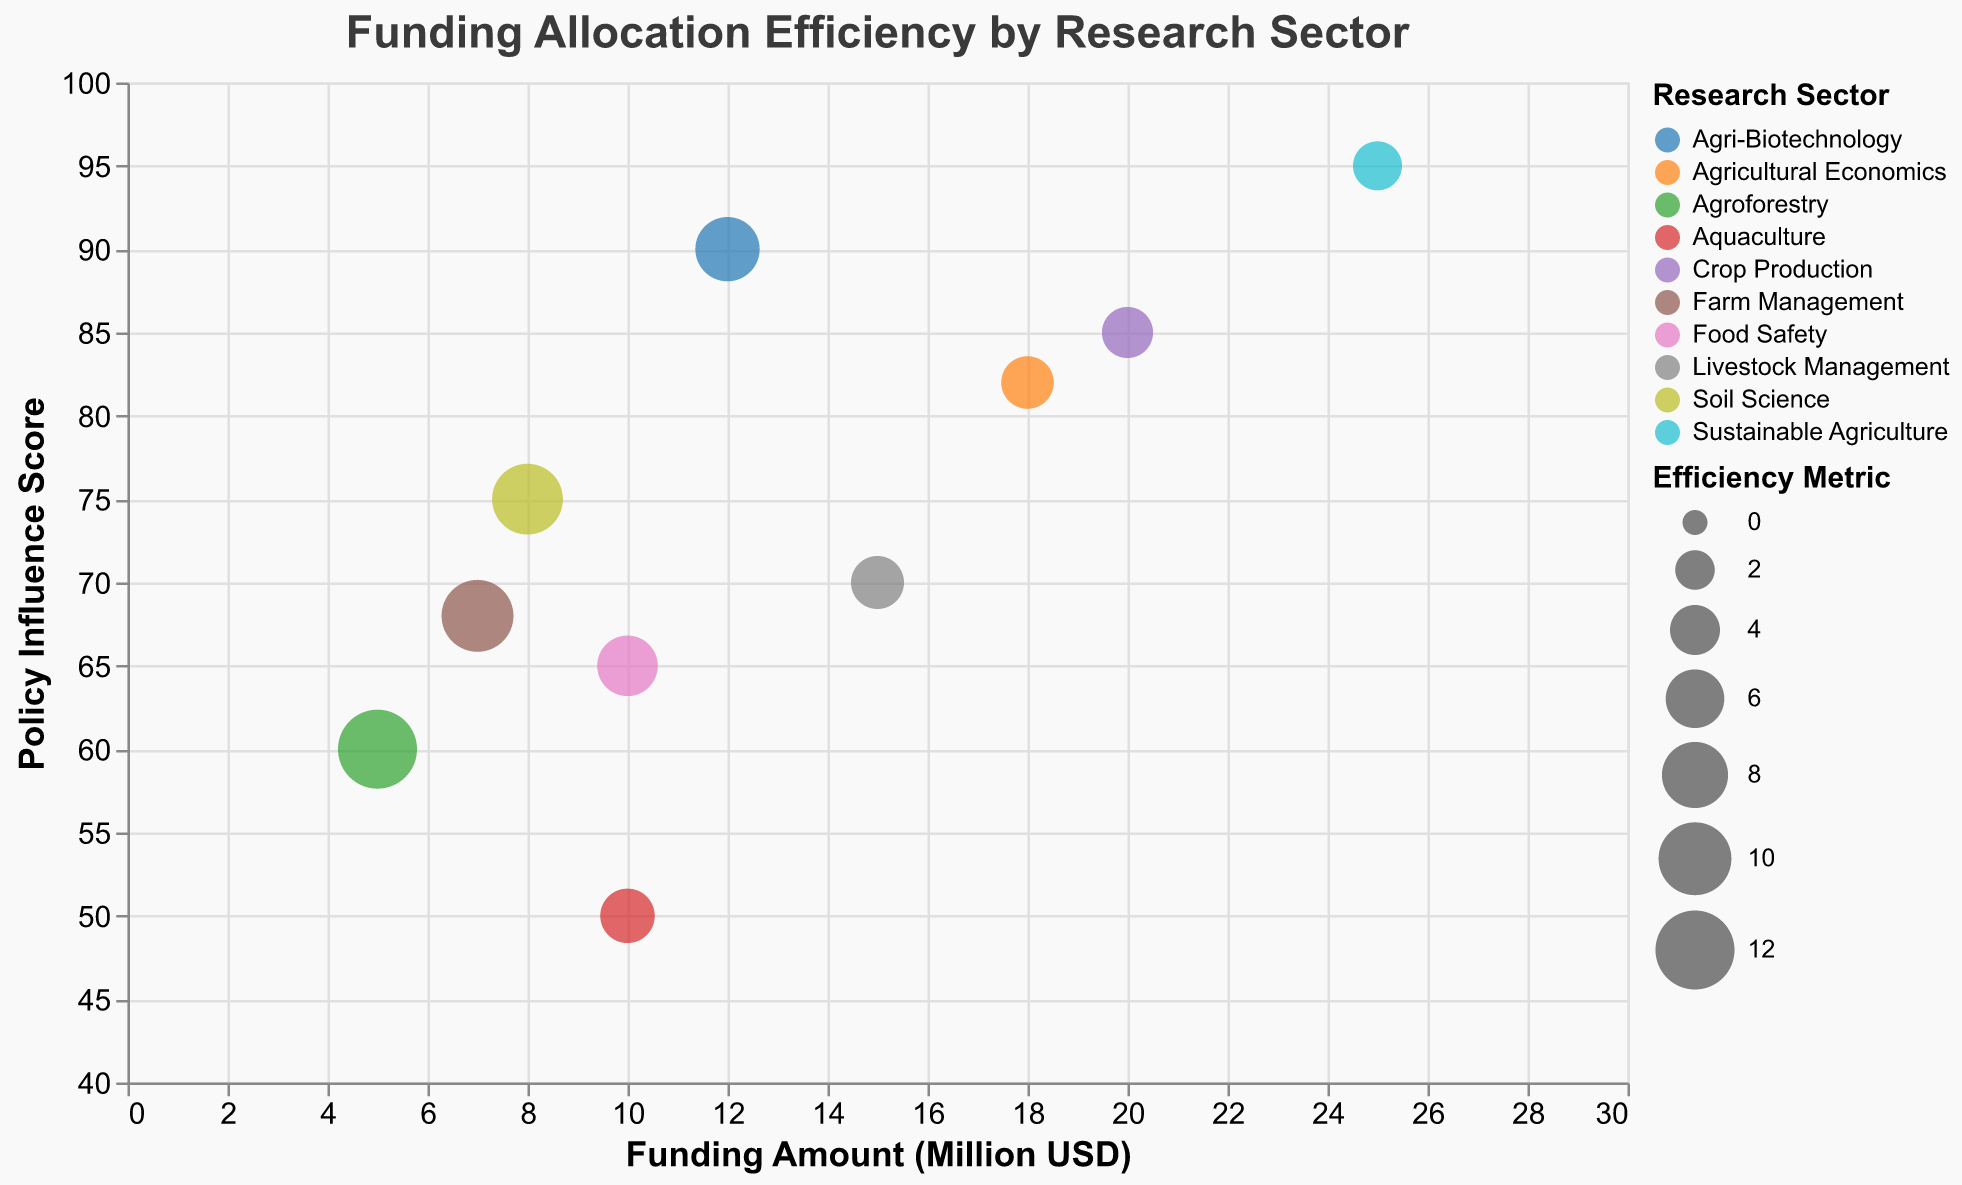How many research sectors are represented in the chart? Count the distinct research sectors listed in the legend and data points.
Answer: 10 Which research sector received the highest funding amount and what is it? Look for the bubble with the highest x-axis value representing the funding amount. The largest funding amount of 25 million USD corresponds to Sustainable Agriculture.
Answer: Sustainable Agriculture, 25 million USD Which research sector has the highest policy influence score? Locate the bubble with the highest y-axis value. The highest policy influence score of 95 corresponds to Sustainable Agriculture.
Answer: Sustainable Agriculture, 95 What is the range of the policy influence scores? Identify the minimum and maximum policy influence scores on the y-axis.
Answer: 50 to 95 Which research sector has the highest efficiency metric? Find the largest bubble by size, as efficiency metric is indicated by bubble size. The largest bubble size corresponds to Agroforestry with an efficiency metric of 12.00.
Answer: Agroforestry, 12.00 Which sector has the lowest funding amount and their corresponding policy influence score? Find the bubble with the smallest x-axis value, representing the lowest funding amount, which is Agroforestry with 5 million USD. The corresponding policy influence score is 60.
Answer: Agroforestry, 60 Compare the efficiency metrics of Crop Production and Agri-Biotechnology. Which one is higher and by how much? Identify the sizes of the bubbles for Crop Production and Agri-Biotechnology, then compute the difference. Efficiency metric of Crop Production is 4.25, while Agri-Biotechnology is 7.50. The difference is 7.50 - 4.25.
Answer: Agri-Biotechnology is higher by 3.25 Which research sector has both a policy influence score above 80 and an efficiency metric greater than 7? Check the y-axis value > 80 and bubble size indicating efficiency metric > 7. Agri-Biotechnology is the sector with a policy influence score of 90 and an efficiency metric of 7.50.
Answer: Agri-Biotechnology What is the median funding amount across all research sectors? List all funding amounts: 20, 15, 5, 10, 8, 12, 25, 18, 7, 10. Order them: 5, 7, 8, 10, 10, 12, 15, 18, 20, 25. The median value is the average of the 5th and 6th terms: (10+12)/2 = 11.
Answer: 11 Is Sustainable Agriculture the least efficient sector based on the efficiency metric? Check the size of the Sustainable Agriculture bubble. The lowest efficiency metric, represented by the smallest bubbles, belongs to Sustainable Agriculture with an efficiency metric of 3.80. Confirm there are no other sectors with a lower metric.
Answer: Yes 